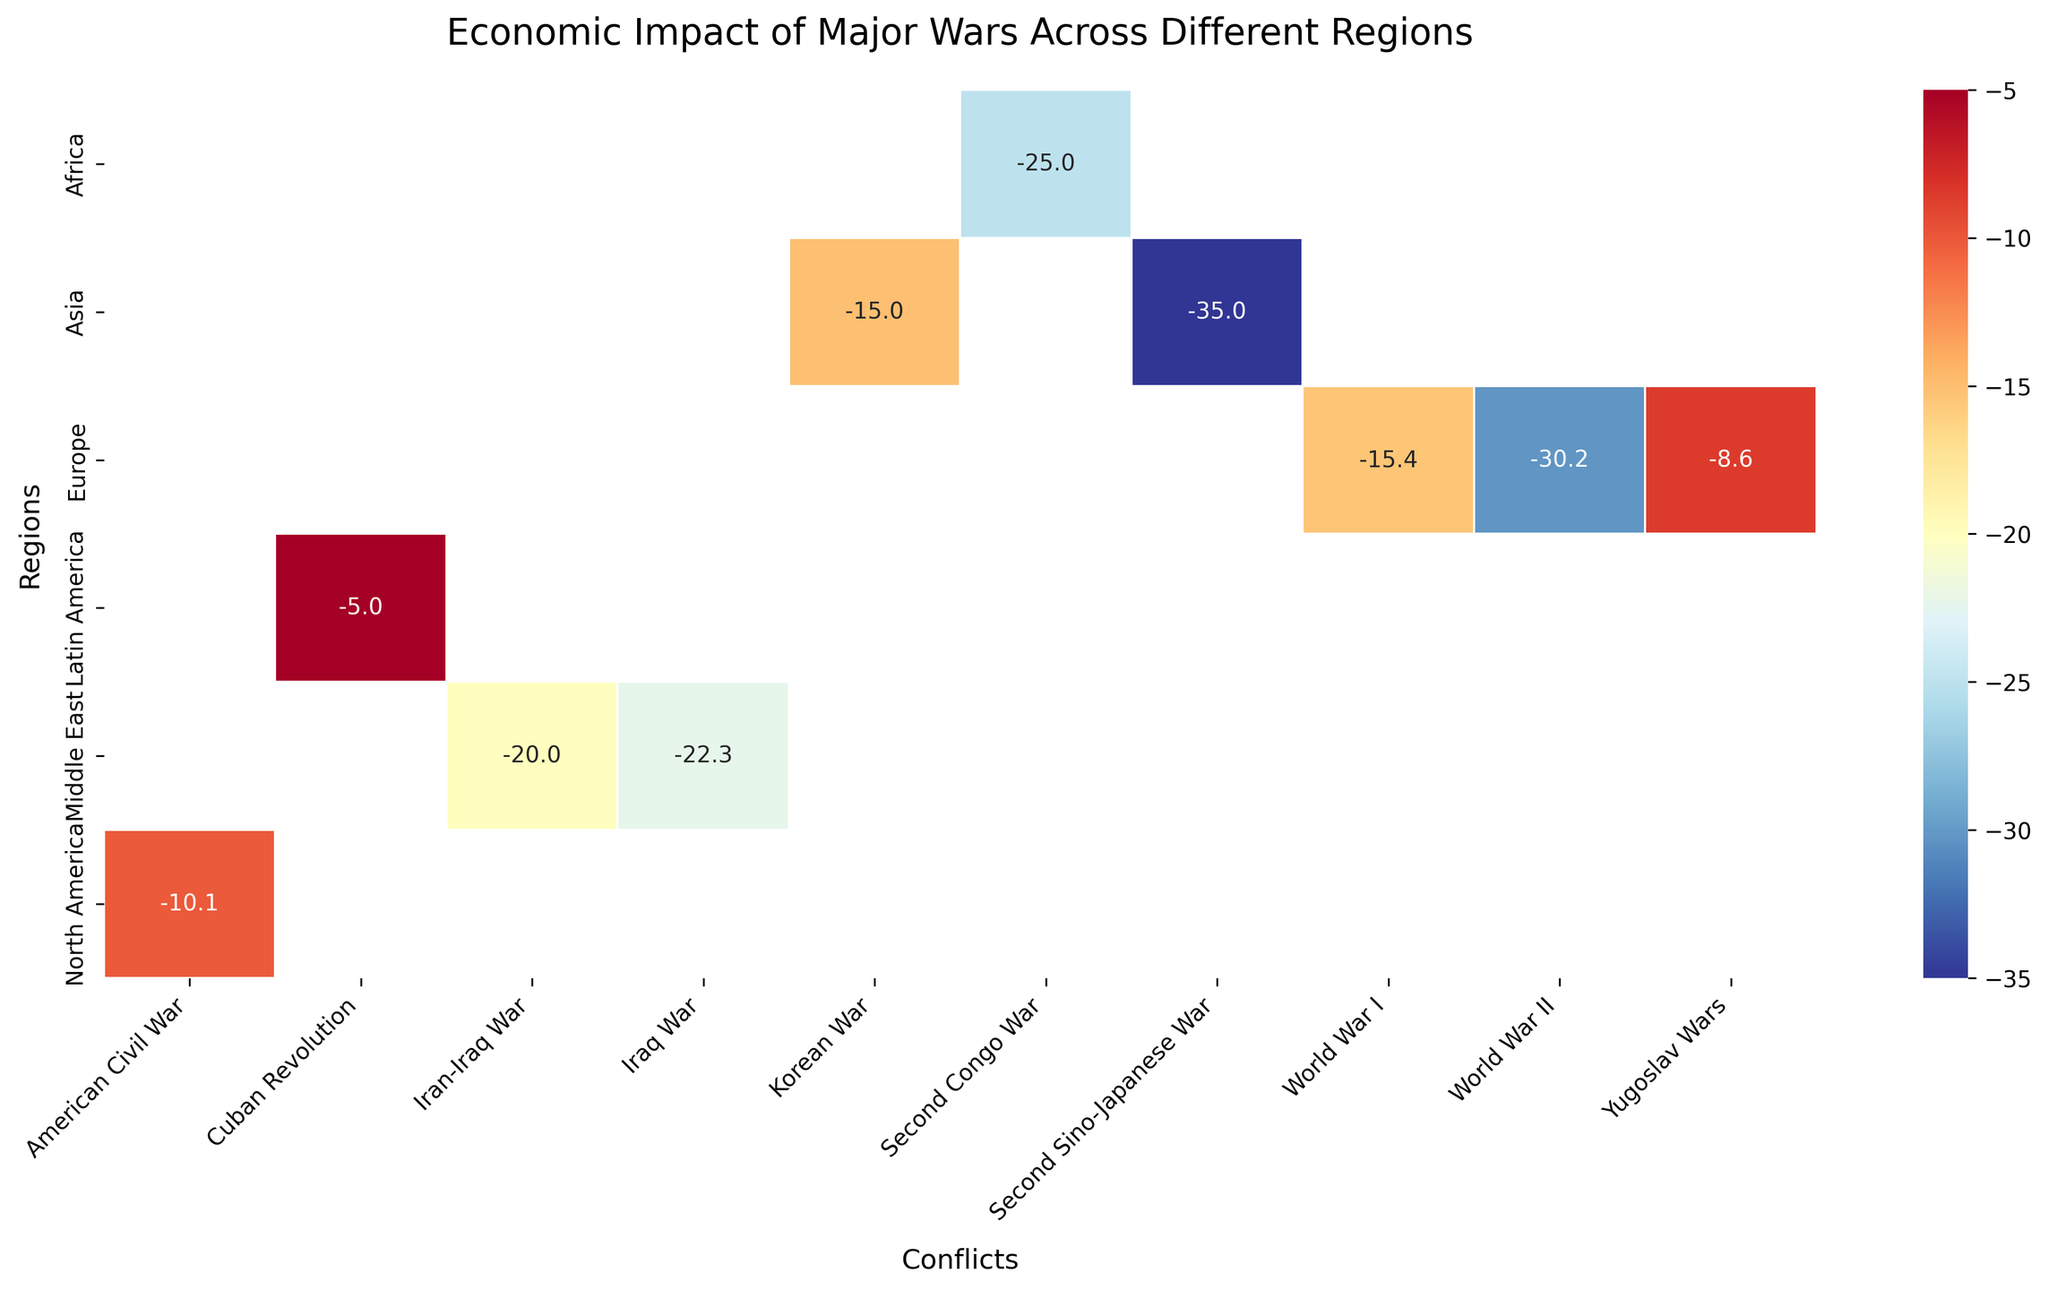what is the title of the heatmap? The title is often placed at the top of a figure, and in this case, it reads "Economic Impact of Major Wars Across Different Regions".
Answer: Economic Impact of Major Wars Across Different Regions Which conflict had the highest negative impact on the Asian region? To determine the highest negative impact in Asia, we look for the conflict with the most negative GDP change in the Asia row of the heatmap.
Answer: Second Sino-Japanese War How much was the economic impact of World War II in Europe? Locate the World War II column and move down to the Europe row to find the economic impact value.
Answer: -30.2% Which region experienced the least economic impact due to conflicts, according to the heatmap? Scan all the rows and identify the region with the least negative or smallest value, regardless of − sign.
Answer: Latin America How does the economic impact of the Korean War in Asia compare to the American Civil War in North America? Compare the values corresponding to the Korean War in the Asia row and the American Civil War in the North America row.
Answer: The Korean War (-15.0%) had a greater negative impact than the American Civil War (-10.1%) Which region had the highest impact in terms of the number of years for reconstruction, given the values in the data were not displayed on the heatmap? Since we do not have the reconstruction time values shown in the heatmap, we cannot directly answer this from the figure itself, but Europe took 15 years after World War II.
Answer: Europe after World War II What is the color scale used in the heatmap, and what does it represent? The color scale ranges from blue to red, with blue representing less negative impacts and red representing more negative impacts. Typically, redder colors indicate a higher negative economic impact (greater percentage drop in GDP).
Answer: RdYlBu_r از Which conflict in the Middle East had a less negative economic impact, the Iran-Iraq War or the Iraq War? Compare the values of the Iran-Iraq War and the Iraq War in the Middle East row to determine which had a lesser negative economic impact.
Answer: Iran-Iraq War (-20.0%) Which conflict shows the smallest economic impact across all regions? Scan all the values on the heatmap and find the conflict with the smallest percentage drop in GDP.
Answer: Cuban Revolution Using the visual information in the heatmap, can you deduce which periods had the most severe economic impacts globally? To deduce this, observe and identify the time periods where multiple regions are showing more red colors, indicating more severe economic impacts.
Answer: 1939-1945 and 1937-1945 